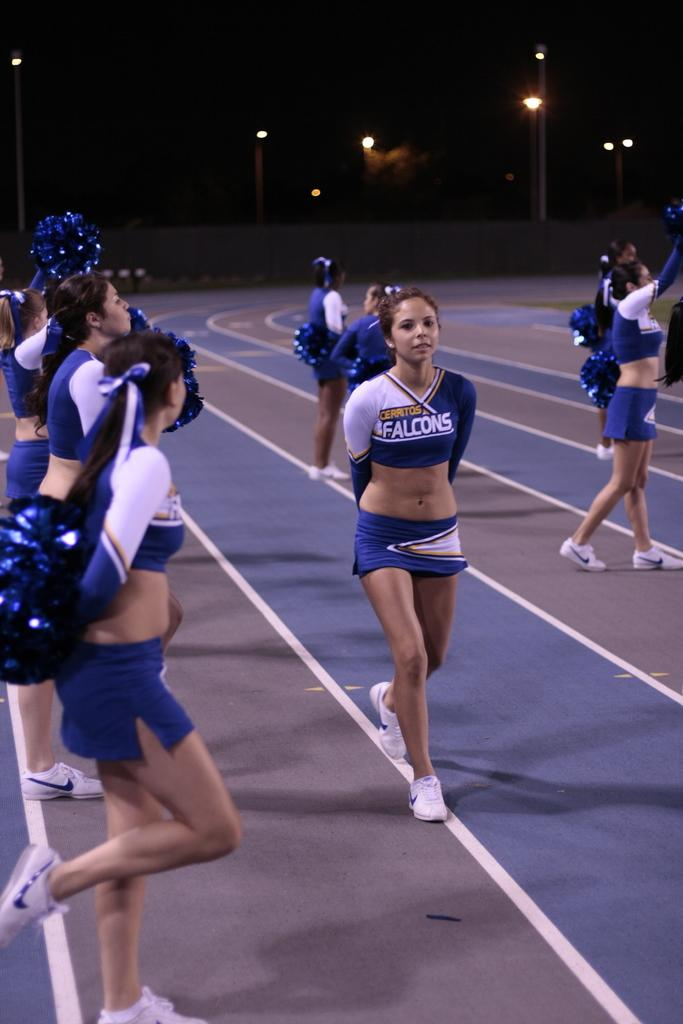<image>
Share a concise interpretation of the image provided. Cerritos Falcons Cheerleaders cheering for a sports game on the track 